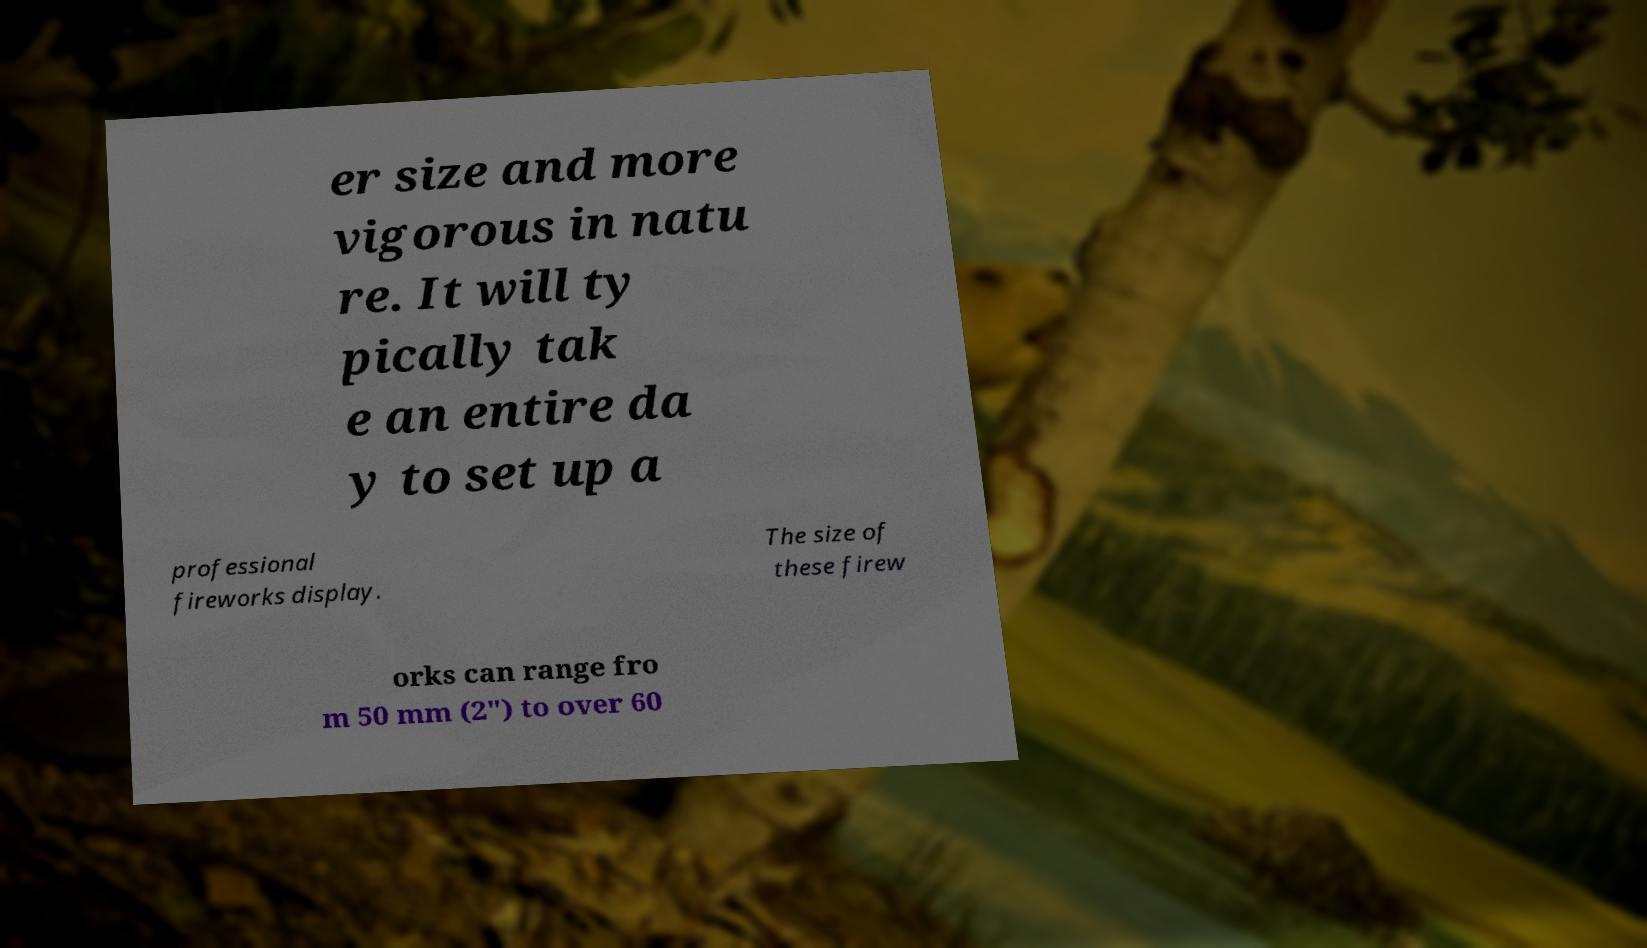Could you extract and type out the text from this image? er size and more vigorous in natu re. It will ty pically tak e an entire da y to set up a professional fireworks display. The size of these firew orks can range fro m 50 mm (2") to over 60 